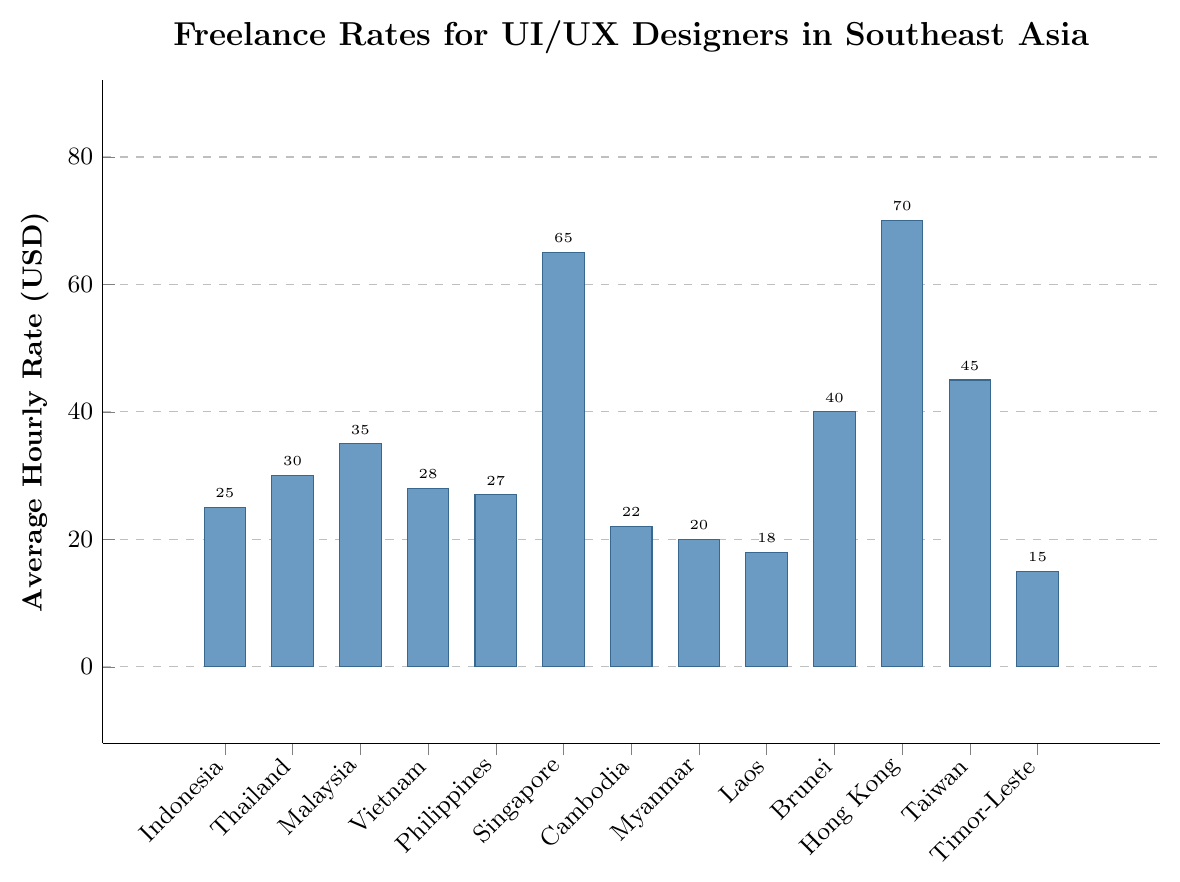What is the average hourly rate for UI/UX designers in Timor-Leste? Look at the bar corresponding to Timor-Leste, which shows the average hourly rate.
Answer: 15 Which country has the highest freelance rate for UI/UX designers? Look at all the bars and identify the highest one, which is for Hong Kong at 70 USD.
Answer: Hong Kong How much higher is the average hourly rate in Singapore compared to Indonesia? The rate in Singapore is 65 USD and in Indonesia is 25 USD. The difference is 65 - 25.
Answer: 40 What is the total average hourly rate for UI/UX designers in Brunei, Malaysia, and Thailand combined? Sum the individual rates: Brunei (40), Malaysia (35), and Thailand (30). 40 + 35 + 30 = 105.
Answer: 105 What is the average of the three lowest freelance rates shown on the chart? Identify the three lowest rates: Timor-Leste (15), Laos (18), and Myanmar (20). Compute the average: (15+18+20)/3 = 53/3.
Answer: 17.67 Which countries have an average hourly rate above 50 USD? Identify bars with heights above the 50 USD mark: Singapore (65 USD) and Hong Kong (70 USD).
Answer: Singapore, Hong Kong What is the difference between the average hourly rate in Taiwan and Vietnam? Look at the rates: Taiwan (45 USD) and Vietnam (28 USD). Compute the difference: 45 - 28.
Answer: 17 How many countries have an average hourly rate of less than 30 USD? Count the bars with heights less than 30 USD: Indonesia, Philippines, Cambodia, Myanmar, Laos, Timor-Leste.
Answer: 6 What is the median value of the average hourly rates? Arrange the rates in ascending order: 15, 18, 20, 22, 25, 27, 28, 30, 35, 40, 45, 65, 70. The middle value (7th in this sorted list) is 28.
Answer: 28 How much more is the average rate in Hong Kong compared to the combined average rates of Laos and Timor-Leste? First get the combined average rate for Laos and Timor-Leste: (18+15)/2 = 16.5. The difference is 70 - 16.5.
Answer: 53.5 